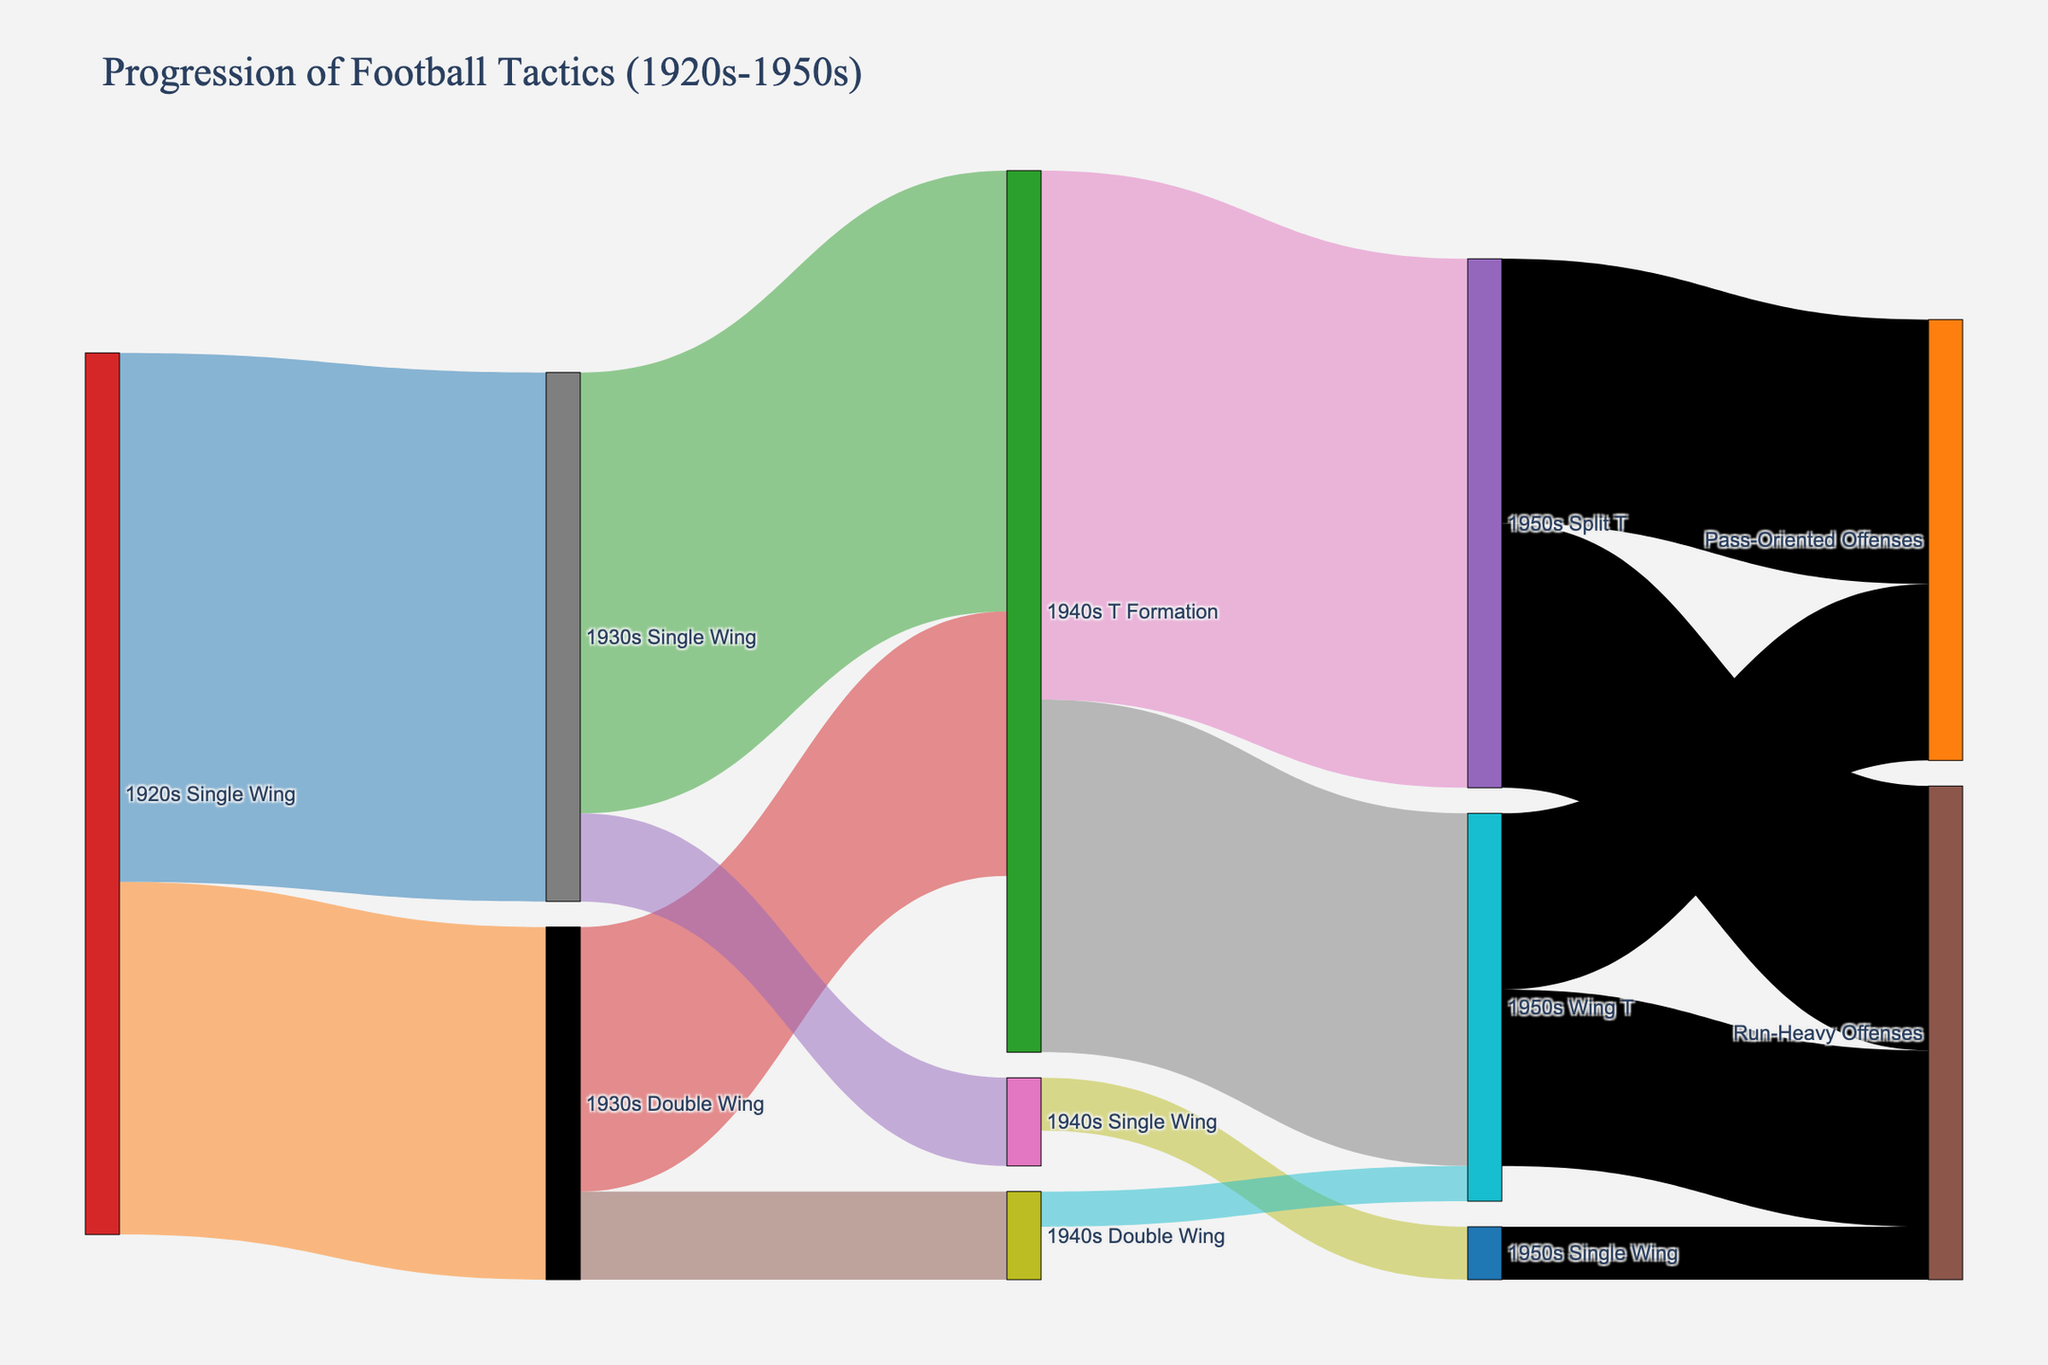What is the title of the figure? The title of the figure is usually located at the top and provides a summary of what the figure is about. In this case, it reads: "Progression of Football Tactics (1920s-1950s)"
Answer: Progression of Football Tactics (1920s-1950s) Which offensive strategy appears to have the highest progression from the 1940s to the 1950s? Identify the lines moving from the 1940s to the 1950s and compare their values. The two main strategies are T Formation to Split T and T Formation to Wing T. Split T has the higher value of 30.
Answer: Split T How many different offensive strategies from the 1930s persisted into the 1940s without changing? Look for arrows that start in the 1930s and end in the 1940s without changing their labels. There are "1930s Single Wing" to "1940s Single Wing" and "1930s Double Wing" to "1940s Double Wing".
Answer: 2 What offensive strategy had the least progression to the 1950s? Identify the smallest values in the links connecting the 1940s to the 1950s. The smallest values link "1940s Double Wing" to "1950s Wing T" and "1940s Single Wing" to "1950s Single Wing" with values of 2 and 3 respectively.
Answer: Double Wing to Wing T and Single Wing to Single Wing What is the total value of offensive strategies starting from 1940s T Formation that transition to the 1950s football tactics? Add the values of the nodes that transition from "1940s T Formation" to any 1950s strategy. 30 (T Formation to Split T) + 20 (T Formation to Wing T) = 50.
Answer: 50 Which two offensive strategies in the 1920s diverged the most in the 1930s and what are their values? Identify the largest difference in values for a single strategy transitioning to multiple targets in the 1930s. The "1920s Single Wing" transitions to "1930s Single Wing" (30) and "1930s Double Wing" (20).
Answer: Single Wing with values 30 and 20 Which strategy in the 1950s had an equal influence on both pass-oriented and run-heavy offenses? Look for values emanating from the same strategy in the 1950s and leading to both "Pass-Oriented Offenses" and "Run-Heavy Offenses". The strategy "1950s Split T" transitions equally to both with values of 15 each.
Answer: Split T How many key stages are depicted in the evolution of football tactics according to the figure? Count the unique timeline stages present in the figure: 1920s, 1930s, 1940s, 1950s, along with "Pass-Oriented Offenses" and "Run-Heavy Offenses". There are five different stages.
Answer: 5 What is the sum of values for offensive strategies directly connecting from the 1940s Single Wing and Double Wing to the 1950s? Add values connecting "1940s Single Wing" and "1940s Double Wing" to "1950s Single Wing" and "1950s Wing T". 3 (Single Wing to Single Wing) + 2 (Double Wing to Wing T) = 5.
Answer: 5 Which decade shows the introduction of the T Formation according to the figure and what are the values associated with each continued strategy into the next decade? Identify when the T Formation first appears and look at the number of T Formation connections. T Formation is introduced in the 1940s with continuations into the 1950s: Split T (30) and Wing T (20).
Answer: 1940s with values 30 and 20 